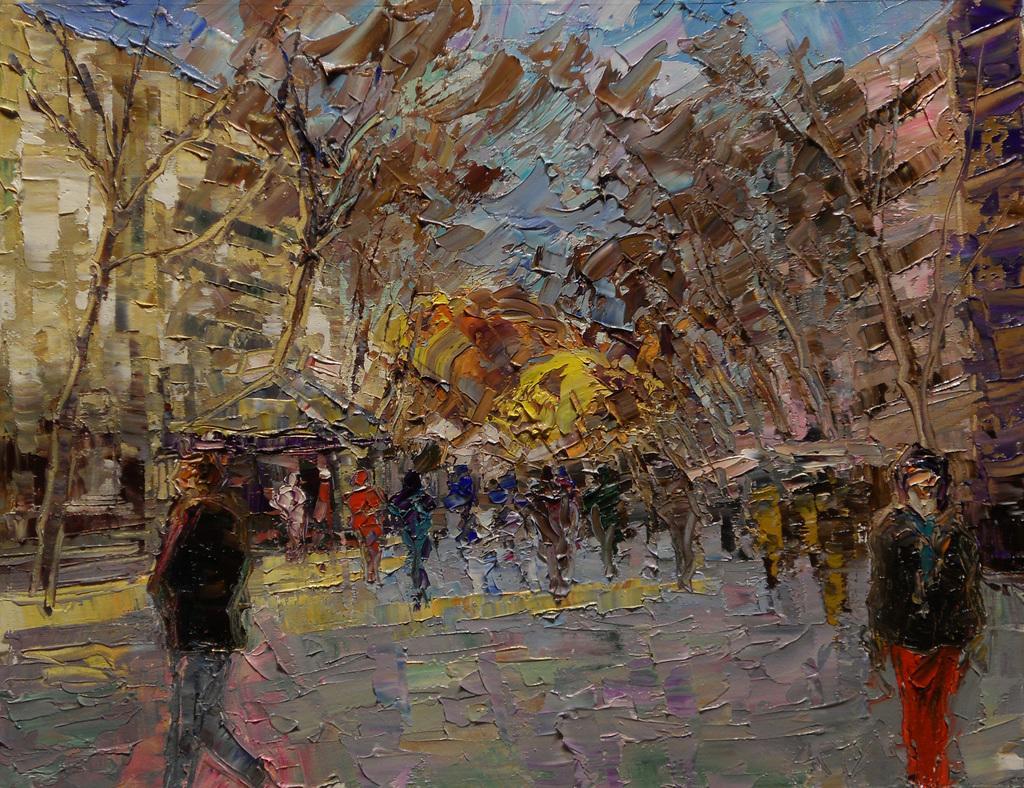Can you describe this image briefly? In this picture I can see the water painting on the wall. In that painting I can see the people, trees, buildings and sky. 